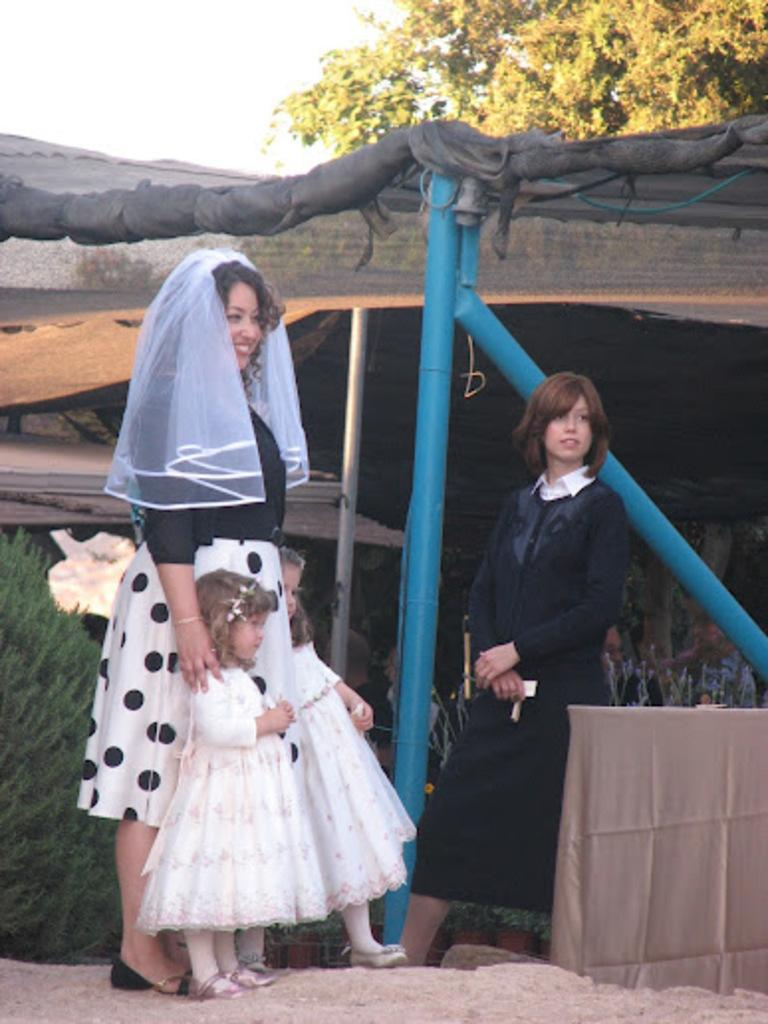Who or what can be seen in the image? There are people in the image. What structures are present in the image? There are poles and a shed in the image. What type of vegetation is visible in the image? There are trees in the image. What is visible at the top of the image? The sky is visible at the top of the image. Can you see any blood on the people in the image? There is no blood visible on the people in the image. What type of view can be seen from the shed in the image? The provided facts do not mention a view from the shed, so it cannot be determined from the image. 